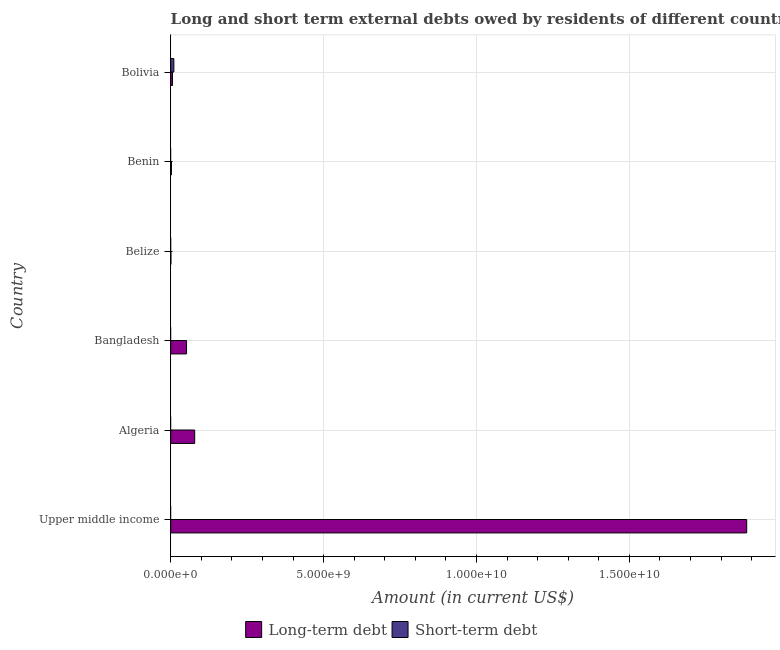Are the number of bars on each tick of the Y-axis equal?
Provide a short and direct response. No. How many bars are there on the 1st tick from the top?
Provide a short and direct response. 2. What is the label of the 3rd group of bars from the top?
Offer a very short reply. Belize. What is the short-term debts owed by residents in Upper middle income?
Provide a short and direct response. 0. Across all countries, what is the maximum short-term debts owed by residents?
Give a very brief answer. 1.03e+08. In which country was the long-term debts owed by residents maximum?
Your answer should be very brief. Upper middle income. What is the total long-term debts owed by residents in the graph?
Your answer should be very brief. 2.02e+1. What is the difference between the long-term debts owed by residents in Algeria and that in Benin?
Your answer should be compact. 7.60e+08. What is the difference between the short-term debts owed by residents in Upper middle income and the long-term debts owed by residents in Belize?
Give a very brief answer. -5.72e+06. What is the average long-term debts owed by residents per country?
Your answer should be very brief. 3.37e+09. In how many countries, is the long-term debts owed by residents greater than 15000000000 US$?
Keep it short and to the point. 1. What is the ratio of the long-term debts owed by residents in Belize to that in Bolivia?
Ensure brevity in your answer.  0.1. What is the difference between the highest and the second highest long-term debts owed by residents?
Offer a very short reply. 1.81e+1. What is the difference between the highest and the lowest long-term debts owed by residents?
Give a very brief answer. 1.88e+1. What is the difference between two consecutive major ticks on the X-axis?
Your answer should be compact. 5.00e+09. How many legend labels are there?
Make the answer very short. 2. What is the title of the graph?
Provide a short and direct response. Long and short term external debts owed by residents of different countries. What is the label or title of the X-axis?
Offer a terse response. Amount (in current US$). What is the Amount (in current US$) of Long-term debt in Upper middle income?
Offer a terse response. 1.88e+1. What is the Amount (in current US$) of Long-term debt in Algeria?
Keep it short and to the point. 7.84e+08. What is the Amount (in current US$) in Short-term debt in Algeria?
Make the answer very short. 0. What is the Amount (in current US$) of Long-term debt in Bangladesh?
Your response must be concise. 5.18e+08. What is the Amount (in current US$) in Short-term debt in Bangladesh?
Provide a short and direct response. 0. What is the Amount (in current US$) in Long-term debt in Belize?
Offer a terse response. 5.72e+06. What is the Amount (in current US$) of Short-term debt in Belize?
Your answer should be very brief. 0. What is the Amount (in current US$) in Long-term debt in Benin?
Your answer should be compact. 2.42e+07. What is the Amount (in current US$) of Short-term debt in Benin?
Your response must be concise. 0. What is the Amount (in current US$) of Long-term debt in Bolivia?
Give a very brief answer. 5.90e+07. What is the Amount (in current US$) of Short-term debt in Bolivia?
Give a very brief answer. 1.03e+08. Across all countries, what is the maximum Amount (in current US$) in Long-term debt?
Provide a short and direct response. 1.88e+1. Across all countries, what is the maximum Amount (in current US$) in Short-term debt?
Your response must be concise. 1.03e+08. Across all countries, what is the minimum Amount (in current US$) of Long-term debt?
Offer a very short reply. 5.72e+06. Across all countries, what is the minimum Amount (in current US$) of Short-term debt?
Ensure brevity in your answer.  0. What is the total Amount (in current US$) in Long-term debt in the graph?
Give a very brief answer. 2.02e+1. What is the total Amount (in current US$) of Short-term debt in the graph?
Provide a succinct answer. 1.03e+08. What is the difference between the Amount (in current US$) in Long-term debt in Upper middle income and that in Algeria?
Offer a terse response. 1.81e+1. What is the difference between the Amount (in current US$) of Long-term debt in Upper middle income and that in Bangladesh?
Ensure brevity in your answer.  1.83e+1. What is the difference between the Amount (in current US$) of Long-term debt in Upper middle income and that in Belize?
Ensure brevity in your answer.  1.88e+1. What is the difference between the Amount (in current US$) of Long-term debt in Upper middle income and that in Benin?
Your answer should be very brief. 1.88e+1. What is the difference between the Amount (in current US$) of Long-term debt in Upper middle income and that in Bolivia?
Your response must be concise. 1.88e+1. What is the difference between the Amount (in current US$) of Long-term debt in Algeria and that in Bangladesh?
Your answer should be very brief. 2.66e+08. What is the difference between the Amount (in current US$) of Long-term debt in Algeria and that in Belize?
Make the answer very short. 7.78e+08. What is the difference between the Amount (in current US$) of Long-term debt in Algeria and that in Benin?
Offer a terse response. 7.60e+08. What is the difference between the Amount (in current US$) of Long-term debt in Algeria and that in Bolivia?
Your answer should be compact. 7.25e+08. What is the difference between the Amount (in current US$) in Long-term debt in Bangladesh and that in Belize?
Your answer should be very brief. 5.12e+08. What is the difference between the Amount (in current US$) in Long-term debt in Bangladesh and that in Benin?
Provide a short and direct response. 4.94e+08. What is the difference between the Amount (in current US$) in Long-term debt in Bangladesh and that in Bolivia?
Provide a succinct answer. 4.59e+08. What is the difference between the Amount (in current US$) in Long-term debt in Belize and that in Benin?
Your answer should be compact. -1.85e+07. What is the difference between the Amount (in current US$) in Long-term debt in Belize and that in Bolivia?
Your answer should be very brief. -5.33e+07. What is the difference between the Amount (in current US$) of Long-term debt in Benin and that in Bolivia?
Your answer should be compact. -3.49e+07. What is the difference between the Amount (in current US$) of Long-term debt in Upper middle income and the Amount (in current US$) of Short-term debt in Bolivia?
Your answer should be very brief. 1.87e+1. What is the difference between the Amount (in current US$) of Long-term debt in Algeria and the Amount (in current US$) of Short-term debt in Bolivia?
Give a very brief answer. 6.81e+08. What is the difference between the Amount (in current US$) in Long-term debt in Bangladesh and the Amount (in current US$) in Short-term debt in Bolivia?
Offer a terse response. 4.15e+08. What is the difference between the Amount (in current US$) in Long-term debt in Belize and the Amount (in current US$) in Short-term debt in Bolivia?
Provide a short and direct response. -9.73e+07. What is the difference between the Amount (in current US$) of Long-term debt in Benin and the Amount (in current US$) of Short-term debt in Bolivia?
Provide a short and direct response. -7.88e+07. What is the average Amount (in current US$) of Long-term debt per country?
Keep it short and to the point. 3.37e+09. What is the average Amount (in current US$) in Short-term debt per country?
Your answer should be very brief. 1.72e+07. What is the difference between the Amount (in current US$) of Long-term debt and Amount (in current US$) of Short-term debt in Bolivia?
Your answer should be very brief. -4.40e+07. What is the ratio of the Amount (in current US$) of Long-term debt in Upper middle income to that in Algeria?
Make the answer very short. 24.03. What is the ratio of the Amount (in current US$) in Long-term debt in Upper middle income to that in Bangladesh?
Your answer should be very brief. 36.38. What is the ratio of the Amount (in current US$) of Long-term debt in Upper middle income to that in Belize?
Provide a succinct answer. 3294.96. What is the ratio of the Amount (in current US$) of Long-term debt in Upper middle income to that in Benin?
Give a very brief answer. 779.05. What is the ratio of the Amount (in current US$) in Long-term debt in Upper middle income to that in Bolivia?
Provide a succinct answer. 319.08. What is the ratio of the Amount (in current US$) of Long-term debt in Algeria to that in Bangladesh?
Make the answer very short. 1.51. What is the ratio of the Amount (in current US$) of Long-term debt in Algeria to that in Belize?
Make the answer very short. 137.1. What is the ratio of the Amount (in current US$) in Long-term debt in Algeria to that in Benin?
Keep it short and to the point. 32.42. What is the ratio of the Amount (in current US$) in Long-term debt in Algeria to that in Bolivia?
Make the answer very short. 13.28. What is the ratio of the Amount (in current US$) of Long-term debt in Bangladesh to that in Belize?
Offer a very short reply. 90.56. What is the ratio of the Amount (in current US$) of Long-term debt in Bangladesh to that in Benin?
Ensure brevity in your answer.  21.41. What is the ratio of the Amount (in current US$) of Long-term debt in Bangladesh to that in Bolivia?
Provide a succinct answer. 8.77. What is the ratio of the Amount (in current US$) in Long-term debt in Belize to that in Benin?
Provide a succinct answer. 0.24. What is the ratio of the Amount (in current US$) of Long-term debt in Belize to that in Bolivia?
Offer a terse response. 0.1. What is the ratio of the Amount (in current US$) in Long-term debt in Benin to that in Bolivia?
Your answer should be compact. 0.41. What is the difference between the highest and the second highest Amount (in current US$) of Long-term debt?
Ensure brevity in your answer.  1.81e+1. What is the difference between the highest and the lowest Amount (in current US$) of Long-term debt?
Provide a short and direct response. 1.88e+1. What is the difference between the highest and the lowest Amount (in current US$) in Short-term debt?
Your answer should be compact. 1.03e+08. 